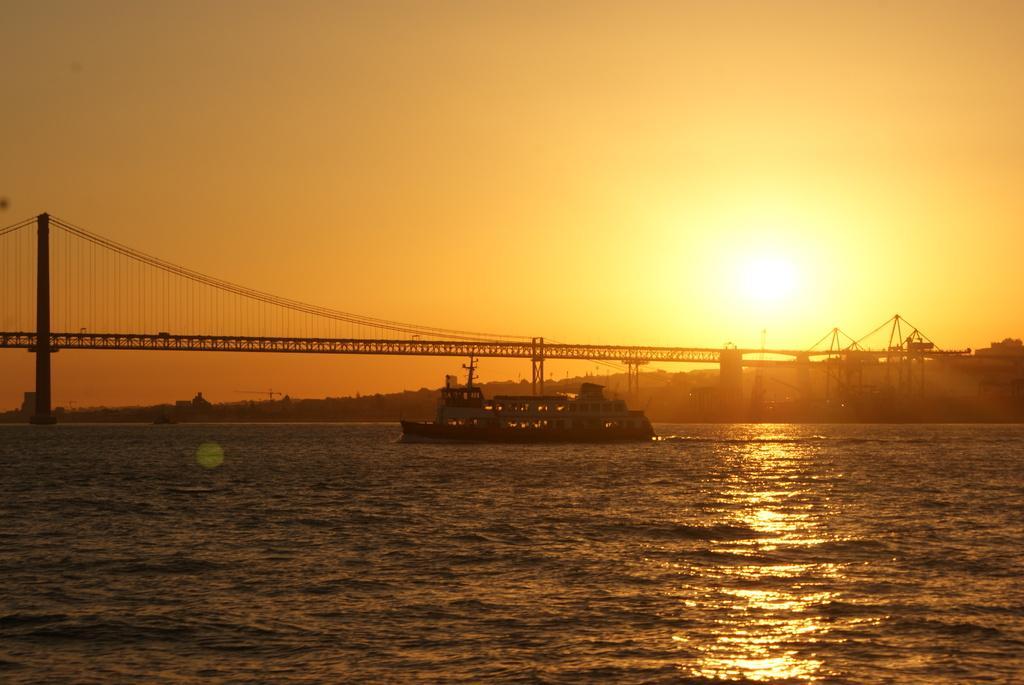How would you summarize this image in a sentence or two? In this picture we can see a ship on water,above the ship there is a bridge and we can see sky in the background. 